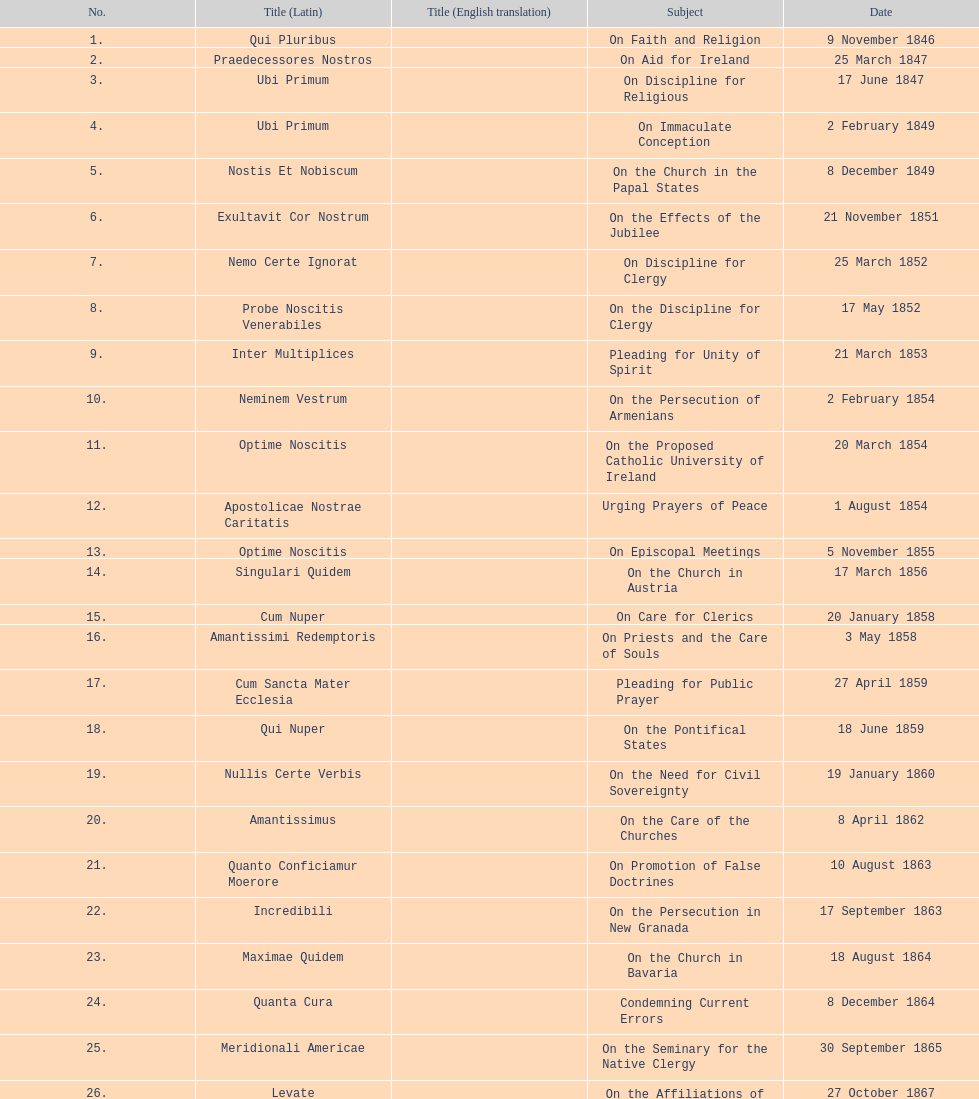What's the overall number of encyclicals related to churches? 11. 